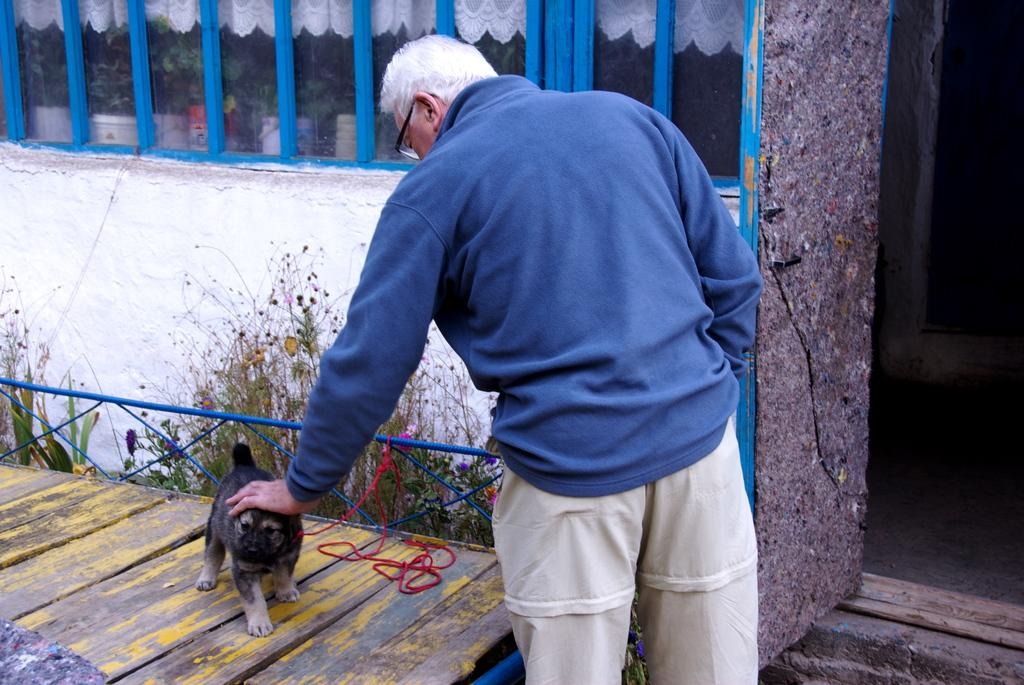Who is present in the image? There is a man in the image. What is the man doing in the image? The man is standing with his hand on a puppy. Where is the puppy located in relation to the man? The puppy is behind the man. What can be seen in the background of the image? There is a wall in the image, and a door is visible on the right side. What type of cough does the man have in the image? There is no indication of a cough in the image; the man is simply standing with his hand on a puppy. What type of teeth can be seen in the image? There are no teeth visible in the image, as it features a man and a puppy, and neither of them has teeth exposed. 